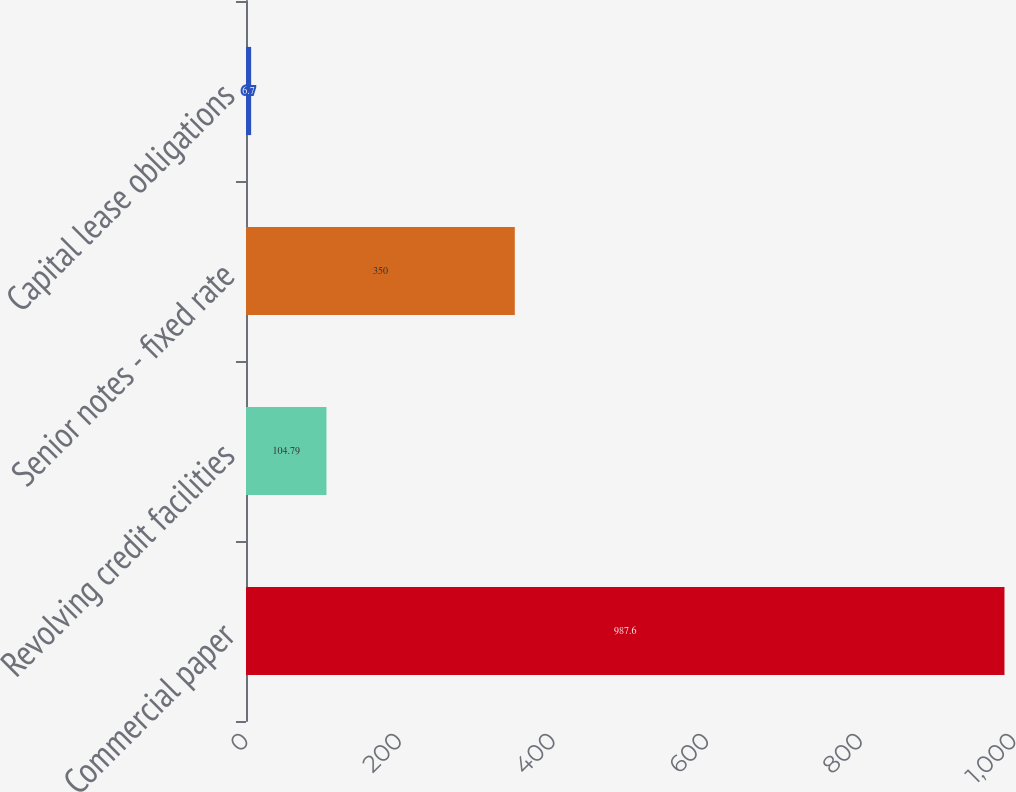Convert chart. <chart><loc_0><loc_0><loc_500><loc_500><bar_chart><fcel>Commercial paper<fcel>Revolving credit facilities<fcel>Senior notes - fixed rate<fcel>Capital lease obligations<nl><fcel>987.6<fcel>104.79<fcel>350<fcel>6.7<nl></chart> 